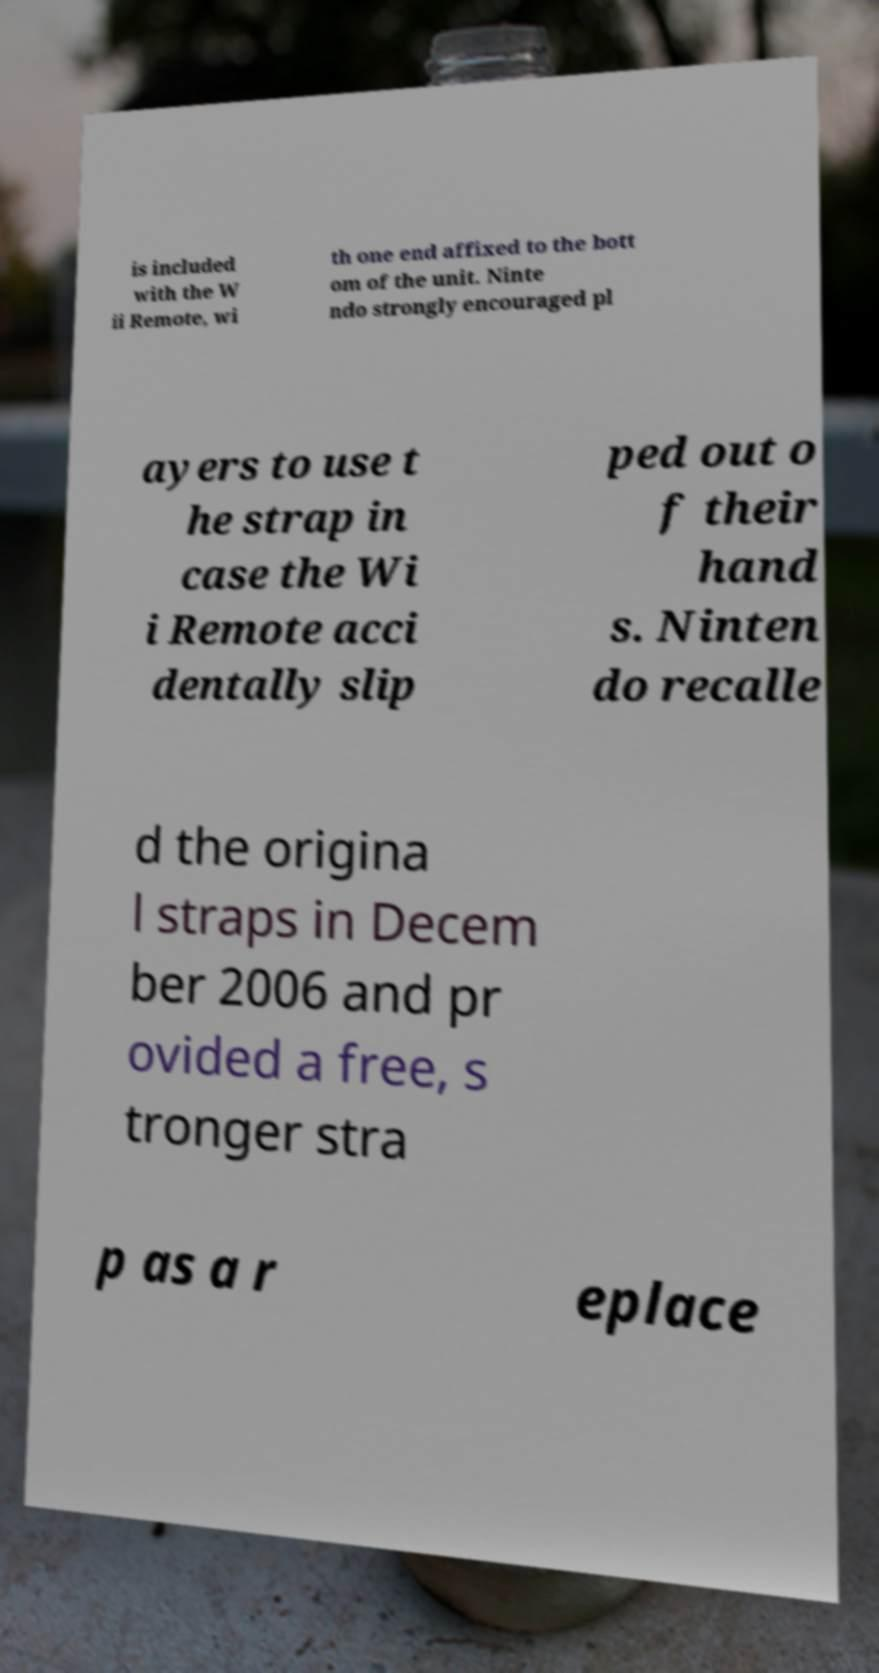Can you read and provide the text displayed in the image?This photo seems to have some interesting text. Can you extract and type it out for me? is included with the W ii Remote, wi th one end affixed to the bott om of the unit. Ninte ndo strongly encouraged pl ayers to use t he strap in case the Wi i Remote acci dentally slip ped out o f their hand s. Ninten do recalle d the origina l straps in Decem ber 2006 and pr ovided a free, s tronger stra p as a r eplace 